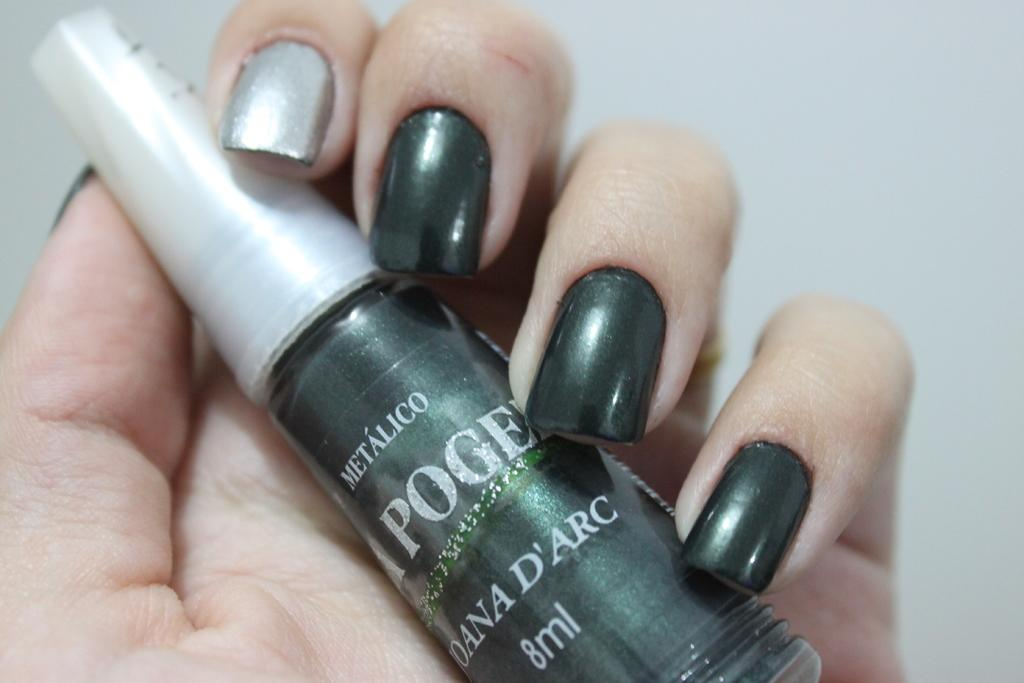<image>
Provide a brief description of the given image. A woman holds a bottle of Metalico nail polish. 